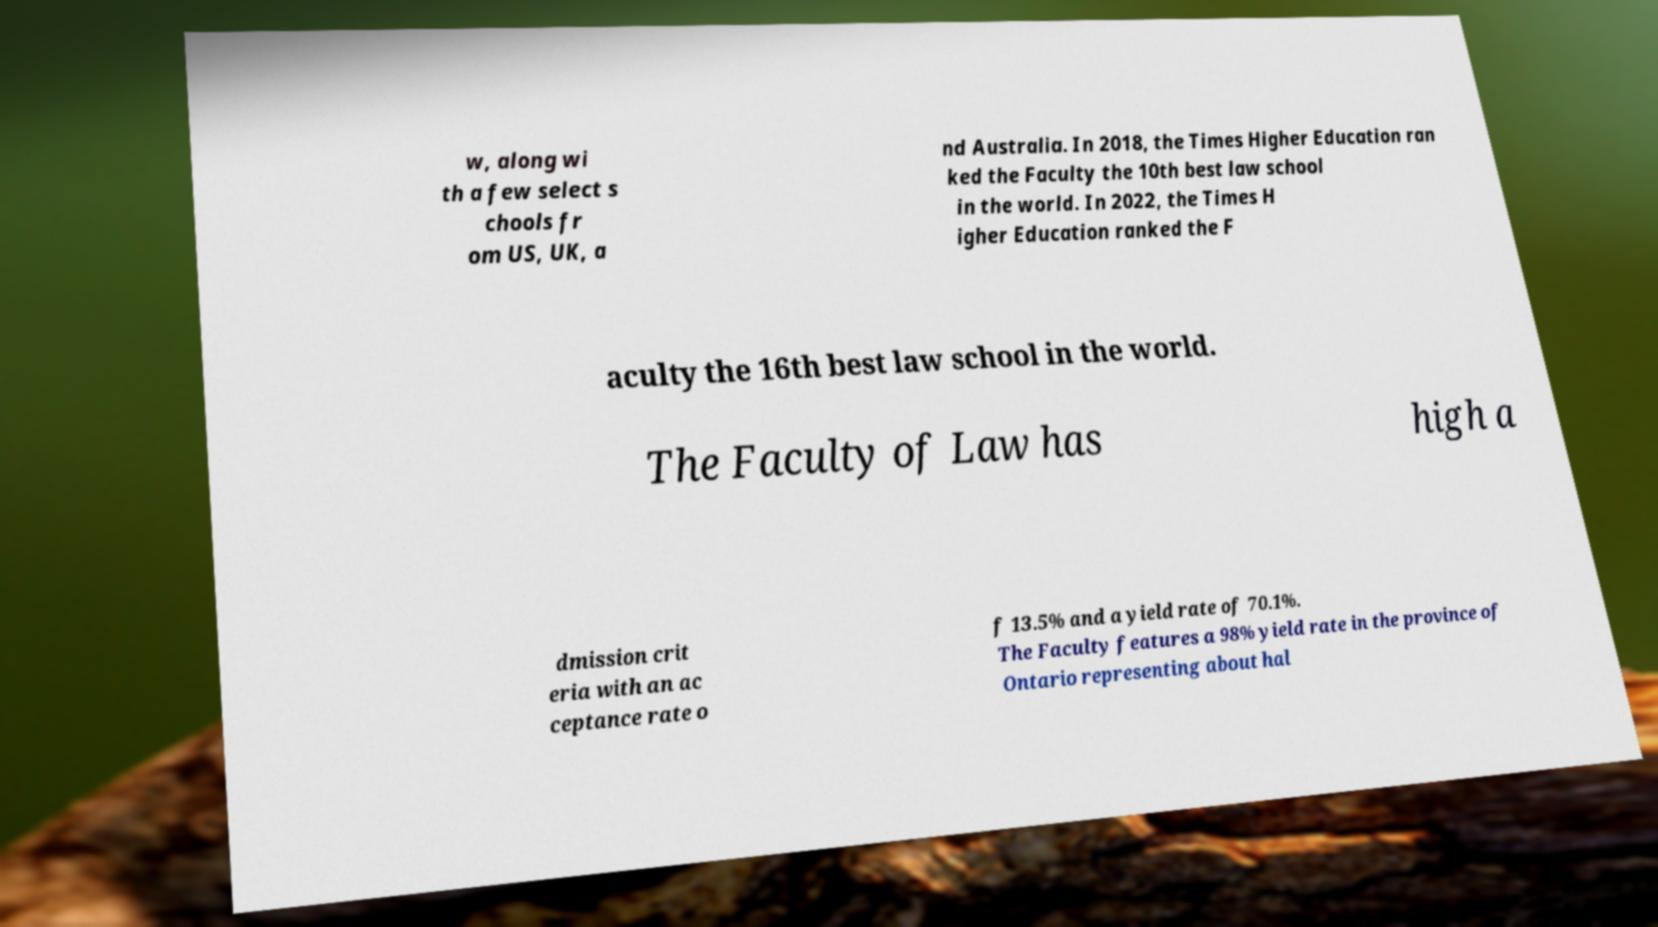Please identify and transcribe the text found in this image. w, along wi th a few select s chools fr om US, UK, a nd Australia. In 2018, the Times Higher Education ran ked the Faculty the 10th best law school in the world. In 2022, the Times H igher Education ranked the F aculty the 16th best law school in the world. The Faculty of Law has high a dmission crit eria with an ac ceptance rate o f 13.5% and a yield rate of 70.1%. The Faculty features a 98% yield rate in the province of Ontario representing about hal 